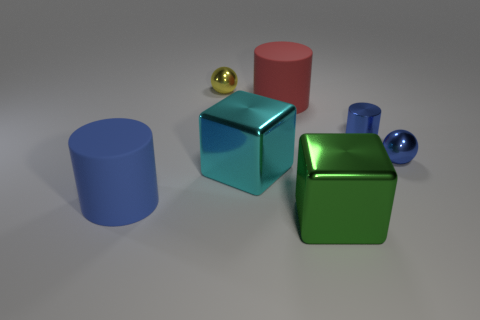The red matte thing has what size?
Provide a succinct answer. Large. There is a cyan shiny object; is its size the same as the rubber object that is behind the blue metallic sphere?
Ensure brevity in your answer.  Yes. There is a metallic ball that is to the left of the shiny ball that is right of the big red cylinder that is behind the small blue ball; what is its color?
Offer a very short reply. Yellow. Are the cyan thing in front of the blue metallic ball and the green cube made of the same material?
Keep it short and to the point. Yes. What number of other things are made of the same material as the cyan object?
Your answer should be very brief. 4. There is a blue sphere that is the same size as the yellow metal object; what material is it?
Your answer should be compact. Metal. There is a blue matte thing on the left side of the large red matte cylinder; is its shape the same as the large metal object that is behind the large green thing?
Your answer should be very brief. No. What shape is the green object that is the same size as the cyan metallic object?
Provide a succinct answer. Cube. Do the ball that is on the right side of the large green cube and the blue thing that is on the left side of the blue metallic cylinder have the same material?
Give a very brief answer. No. Are there any large blue matte things behind the ball to the right of the red thing?
Your answer should be compact. No. 